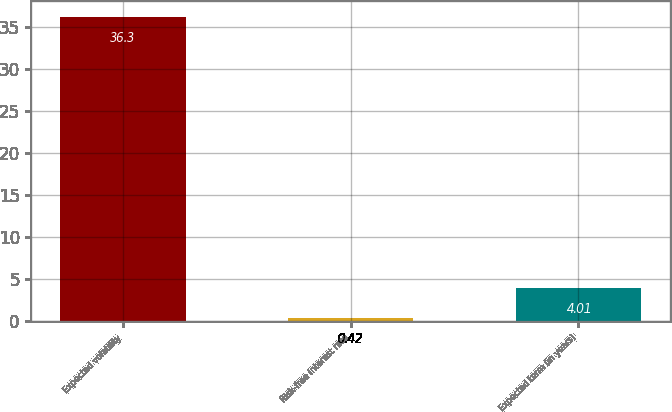<chart> <loc_0><loc_0><loc_500><loc_500><bar_chart><fcel>Expected volatility<fcel>Risk-free interest rate<fcel>Expected term (in years)<nl><fcel>36.3<fcel>0.42<fcel>4.01<nl></chart> 